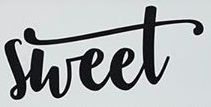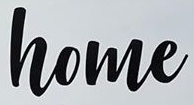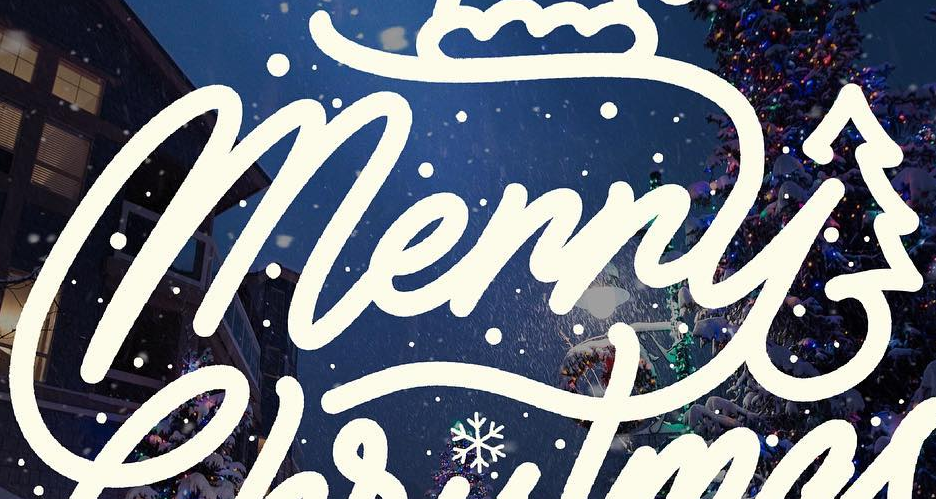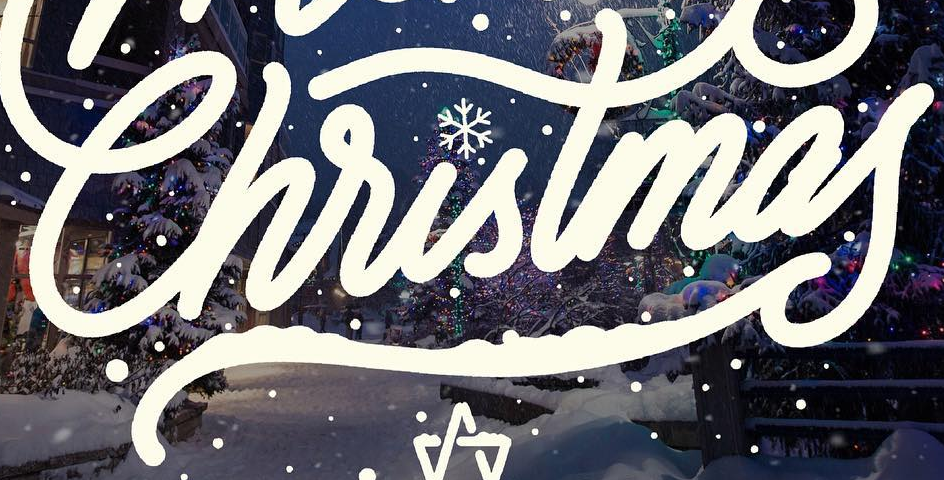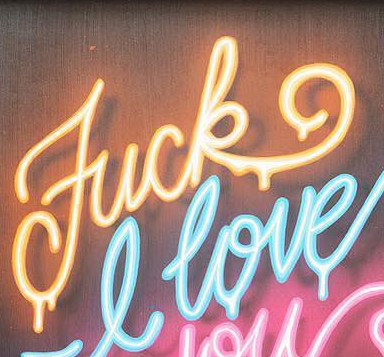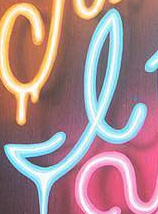What words are shown in these images in order, separated by a semicolon? sheet; home; Merry; Christmas; Fuck; I 